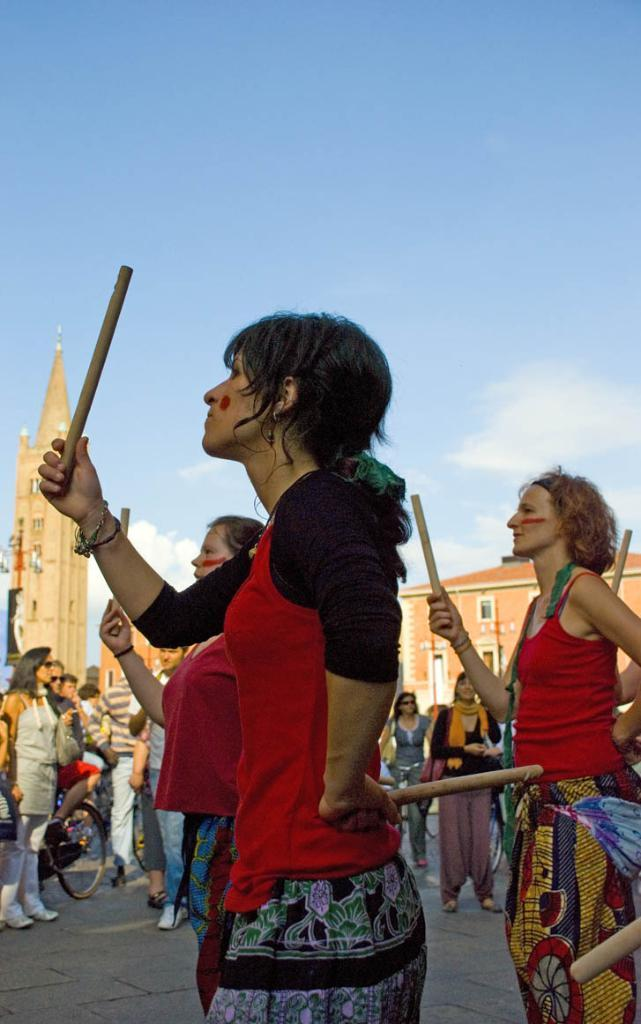What is happening in the image involving a group of people? The people in the image are performing something, and they are holding sticks. Are there any other people in the image besides the performers? Yes, there are people standing nearby. What can be seen in the background of the image? There is a church visible in the background. What type of rail is being used by the performers in the image? There is no rail present in the image; the performers are holding sticks. What song are the performers singing in the image? The image does not provide any information about the song being sung by the performers. 